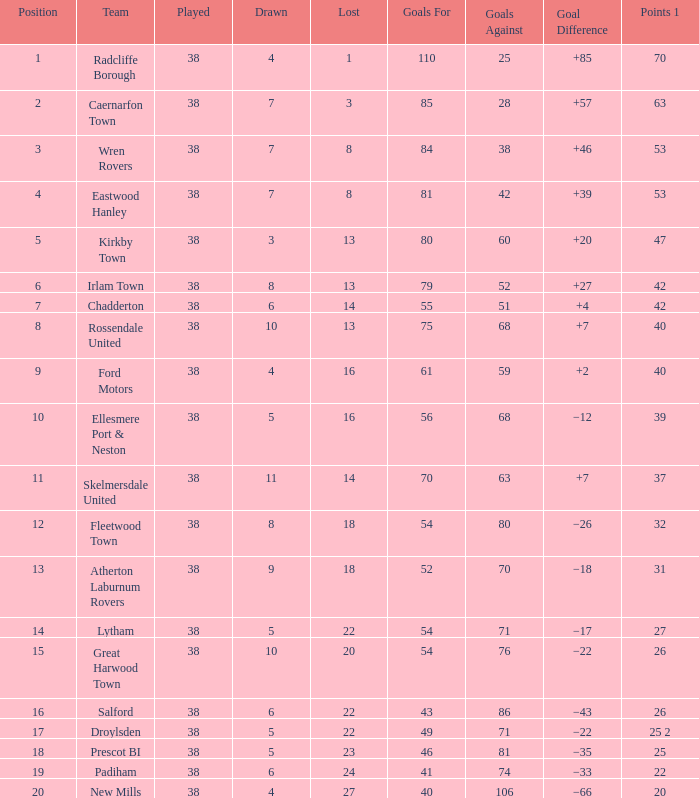Would you be able to parse every entry in this table? {'header': ['Position', 'Team', 'Played', 'Drawn', 'Lost', 'Goals For', 'Goals Against', 'Goal Difference', 'Points 1'], 'rows': [['1', 'Radcliffe Borough', '38', '4', '1', '110', '25', '+85', '70'], ['2', 'Caernarfon Town', '38', '7', '3', '85', '28', '+57', '63'], ['3', 'Wren Rovers', '38', '7', '8', '84', '38', '+46', '53'], ['4', 'Eastwood Hanley', '38', '7', '8', '81', '42', '+39', '53'], ['5', 'Kirkby Town', '38', '3', '13', '80', '60', '+20', '47'], ['6', 'Irlam Town', '38', '8', '13', '79', '52', '+27', '42'], ['7', 'Chadderton', '38', '6', '14', '55', '51', '+4', '42'], ['8', 'Rossendale United', '38', '10', '13', '75', '68', '+7', '40'], ['9', 'Ford Motors', '38', '4', '16', '61', '59', '+2', '40'], ['10', 'Ellesmere Port & Neston', '38', '5', '16', '56', '68', '−12', '39'], ['11', 'Skelmersdale United', '38', '11', '14', '70', '63', '+7', '37'], ['12', 'Fleetwood Town', '38', '8', '18', '54', '80', '−26', '32'], ['13', 'Atherton Laburnum Rovers', '38', '9', '18', '52', '70', '−18', '31'], ['14', 'Lytham', '38', '5', '22', '54', '71', '−17', '27'], ['15', 'Great Harwood Town', '38', '10', '20', '54', '76', '−22', '26'], ['16', 'Salford', '38', '6', '22', '43', '86', '−43', '26'], ['17', 'Droylsden', '38', '5', '22', '49', '71', '−22', '25 2'], ['18', 'Prescot BI', '38', '5', '23', '46', '81', '−35', '25'], ['19', 'Padiham', '38', '6', '24', '41', '74', '−33', '22'], ['20', 'New Mills', '38', '4', '27', '40', '106', '−66', '20']]} How much Drawn has Goals Against of 81, and a Lost larger than 23? 0.0. 